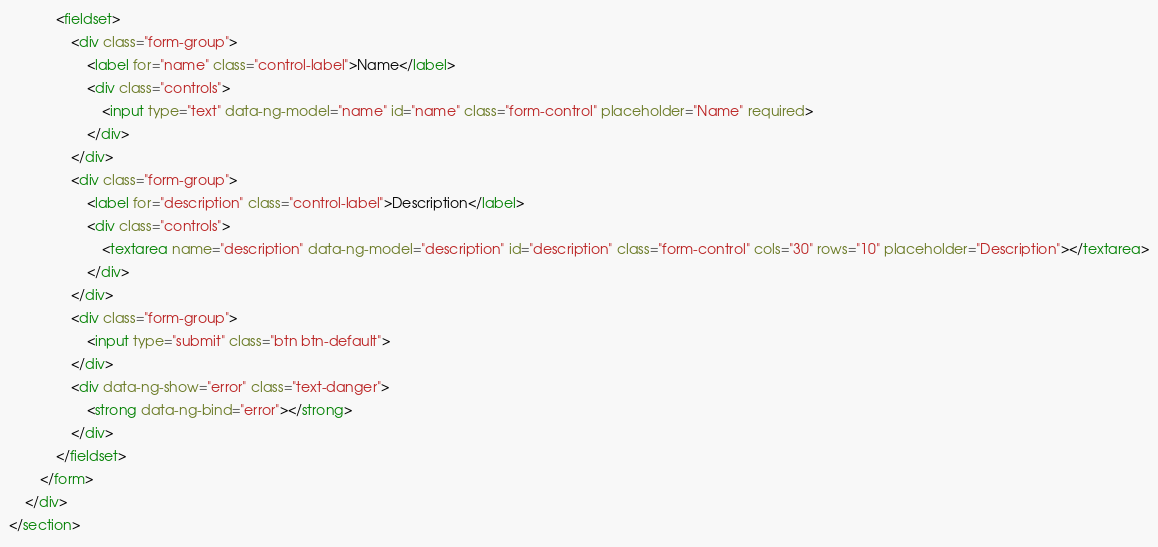Convert code to text. <code><loc_0><loc_0><loc_500><loc_500><_HTML_>            <fieldset>
                <div class="form-group">
                    <label for="name" class="control-label">Name</label>
                    <div class="controls">
                        <input type="text" data-ng-model="name" id="name" class="form-control" placeholder="Name" required>
                    </div>
                </div>
                <div class="form-group">
                    <label for="description" class="control-label">Description</label>
                    <div class="controls">
                        <textarea name="description" data-ng-model="description" id="description" class="form-control" cols="30" rows="10" placeholder="Description"></textarea>
                    </div>
                </div>
                <div class="form-group">
                    <input type="submit" class="btn btn-default">
                </div>
                <div data-ng-show="error" class="text-danger">
                    <strong data-ng-bind="error"></strong>
                </div>
            </fieldset>
        </form>
    </div>
</section></code> 